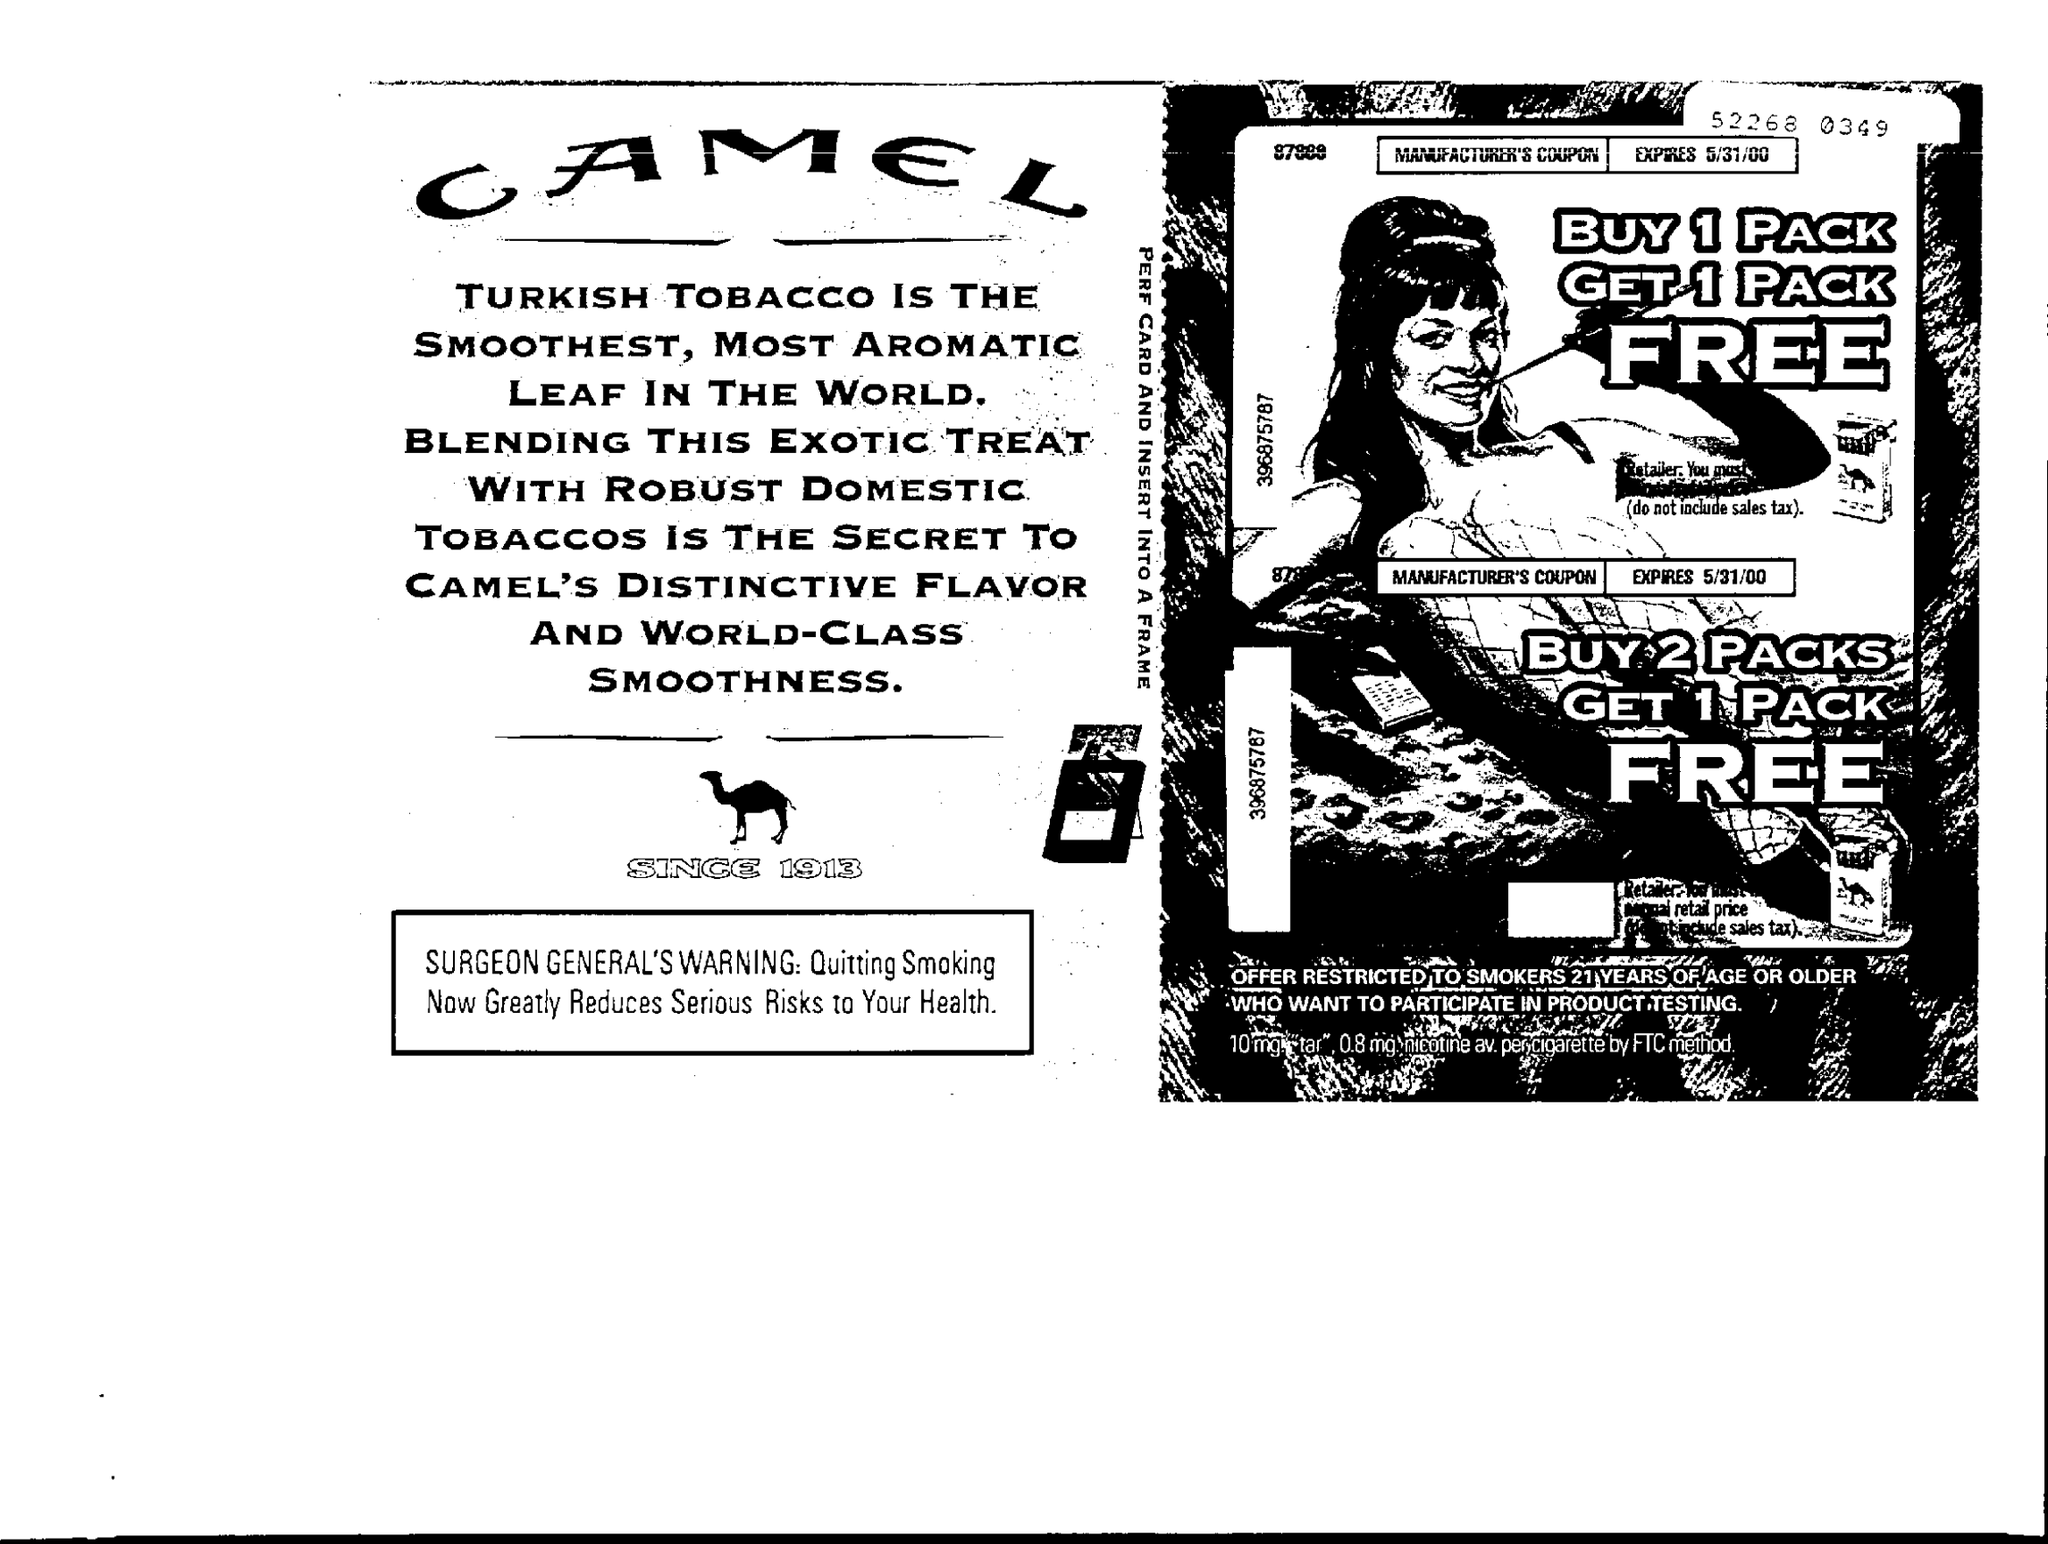When does the Coupon Expire?
Give a very brief answer. 5/31/00. 